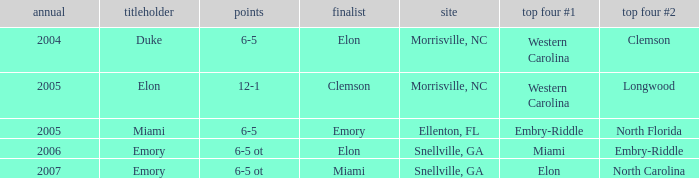Where was the final game played in 2007 Snellville, GA. 